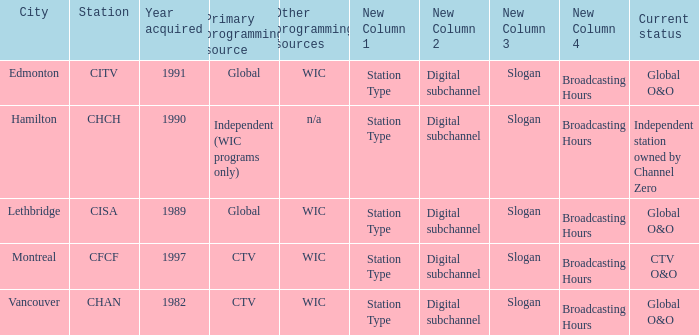Where is citv located Edmonton. 